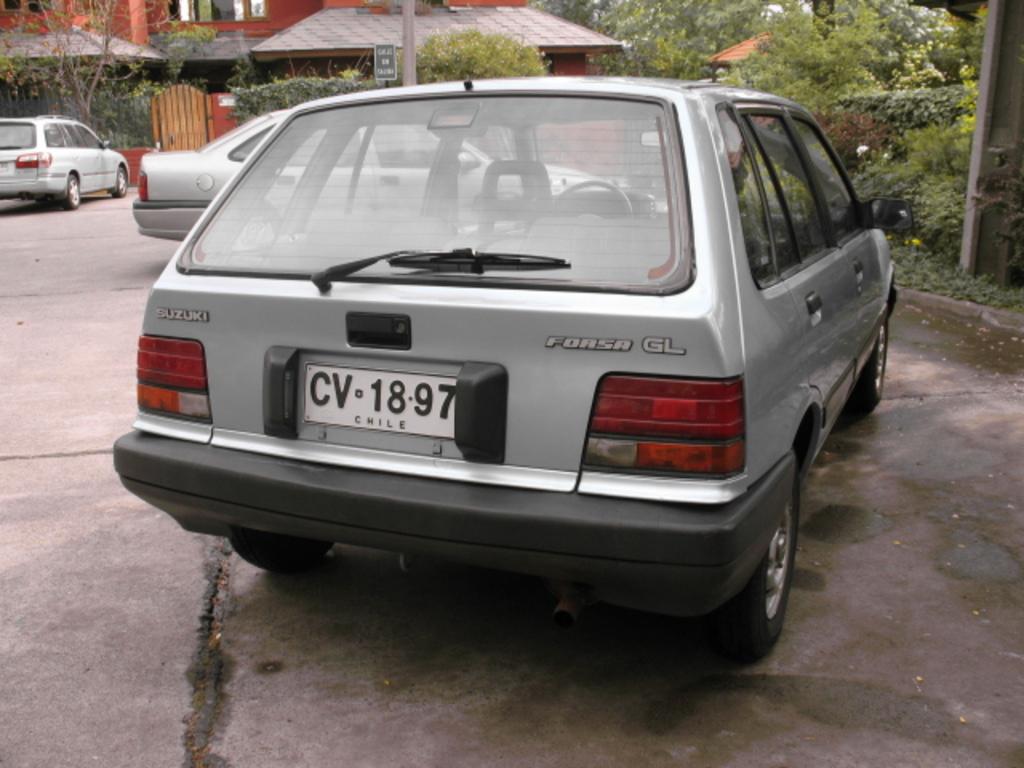What country is mentioned on the license plate?
Your answer should be compact. Chile. What company made the car?
Your answer should be very brief. Suzuki. 